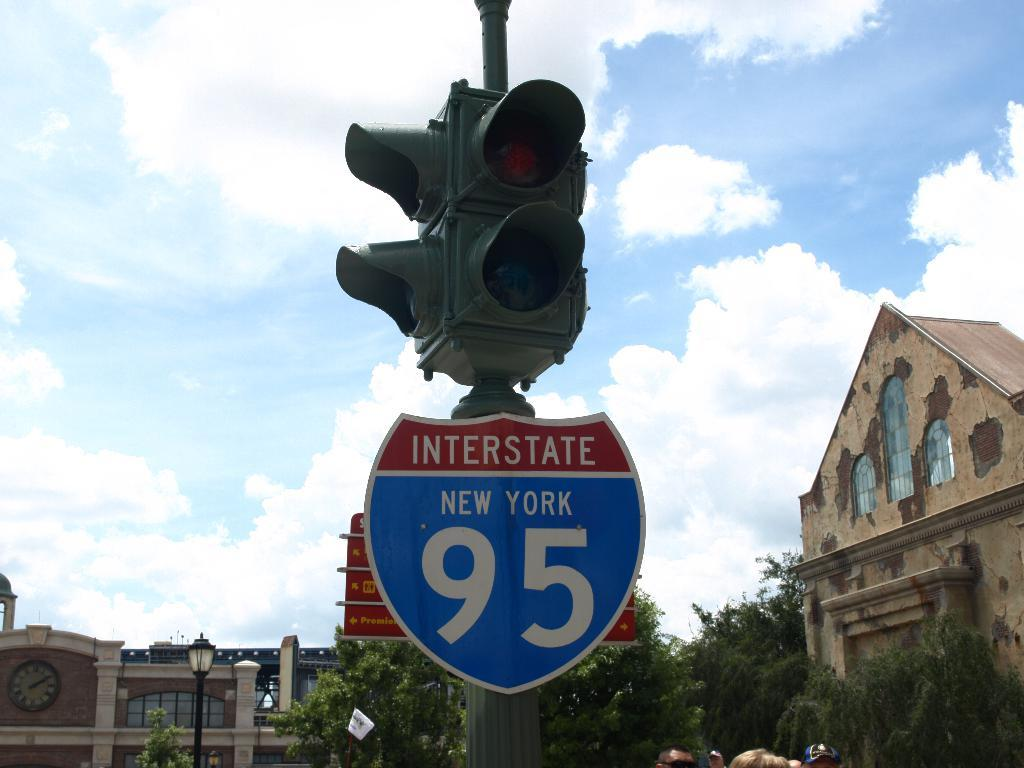<image>
Offer a succinct explanation of the picture presented. a sign from route 95 through New York is on a stop light 